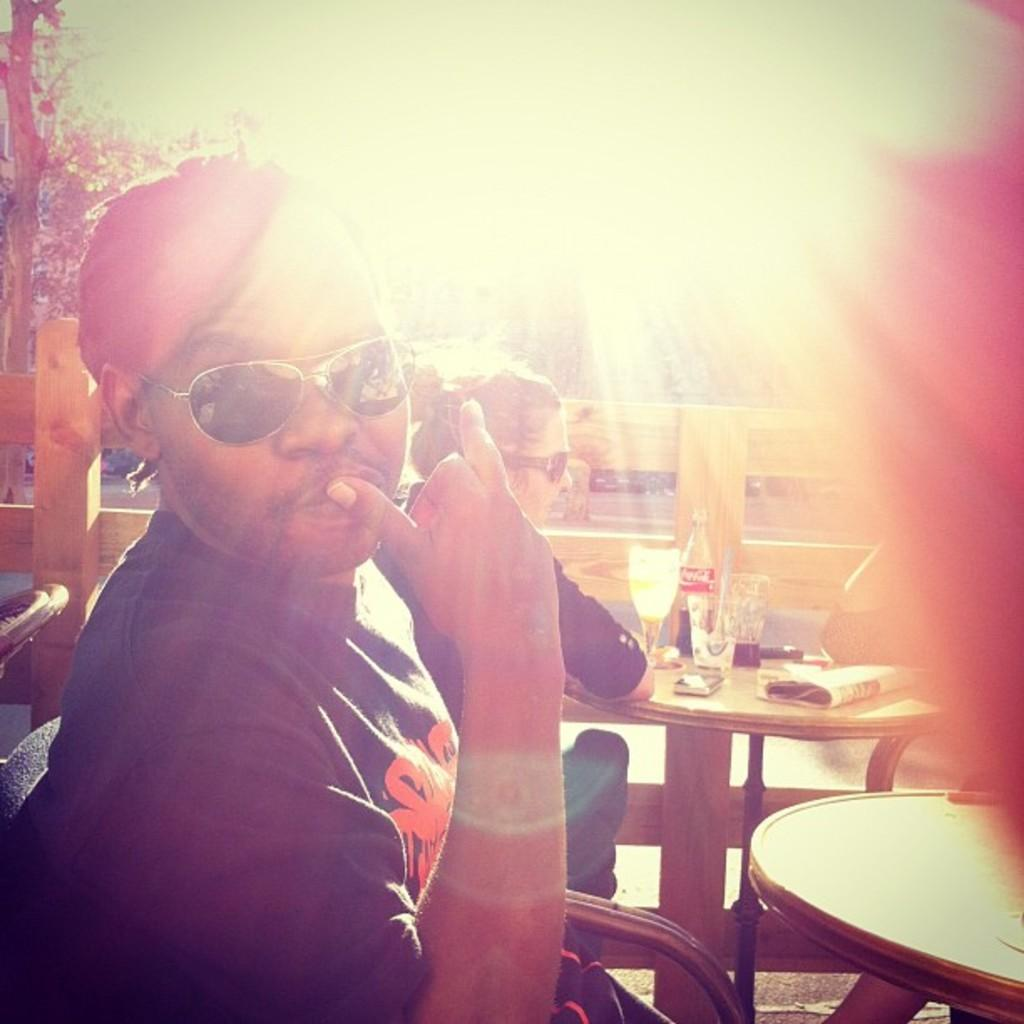What is the position of the man in the image? The man is seated on a chair in the image. What is the man wearing on his head? The man is wearing a cap in the image. What type of eyewear is the man wearing? The man is wearing sunglasses in the image. Can you describe the woman's position in the image? The woman is seated in the image. What type of copper scent can be detected in the image? There is no mention of copper or scent in the image, so it cannot be determined if any such scent is present. 